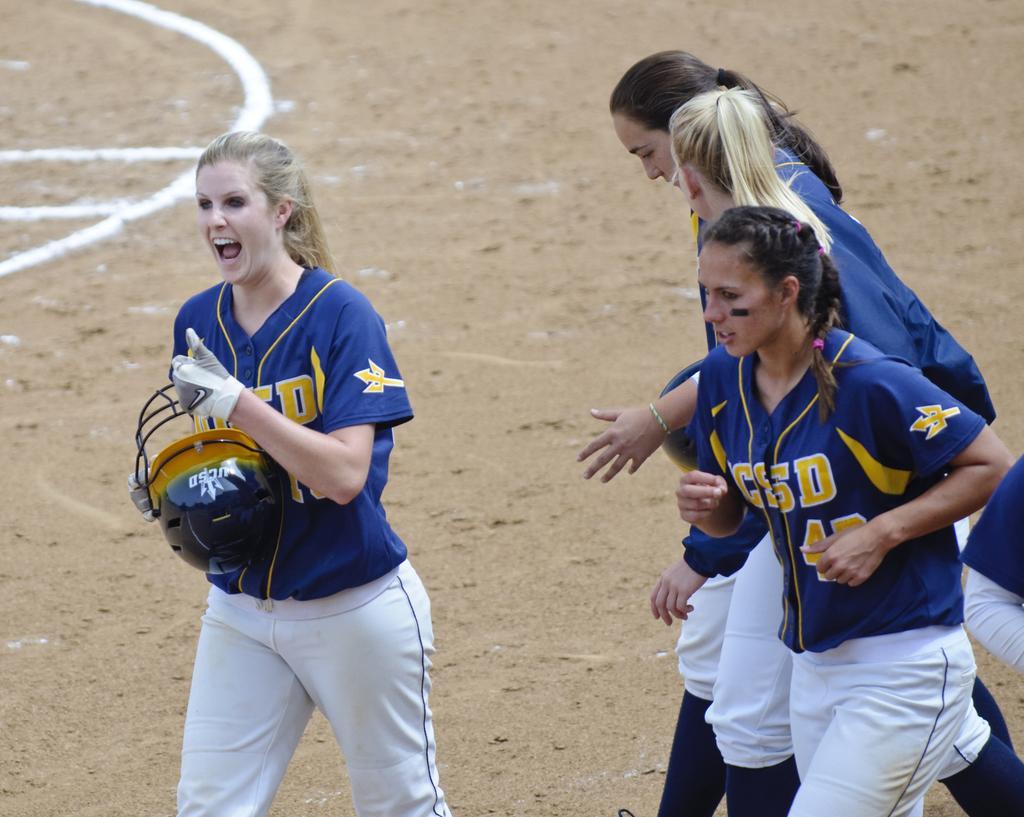In one or two sentences, can you explain what this image depicts? In this image we can see five persons. A lady is holding a helmet in her hand. There is a ground in the image. 